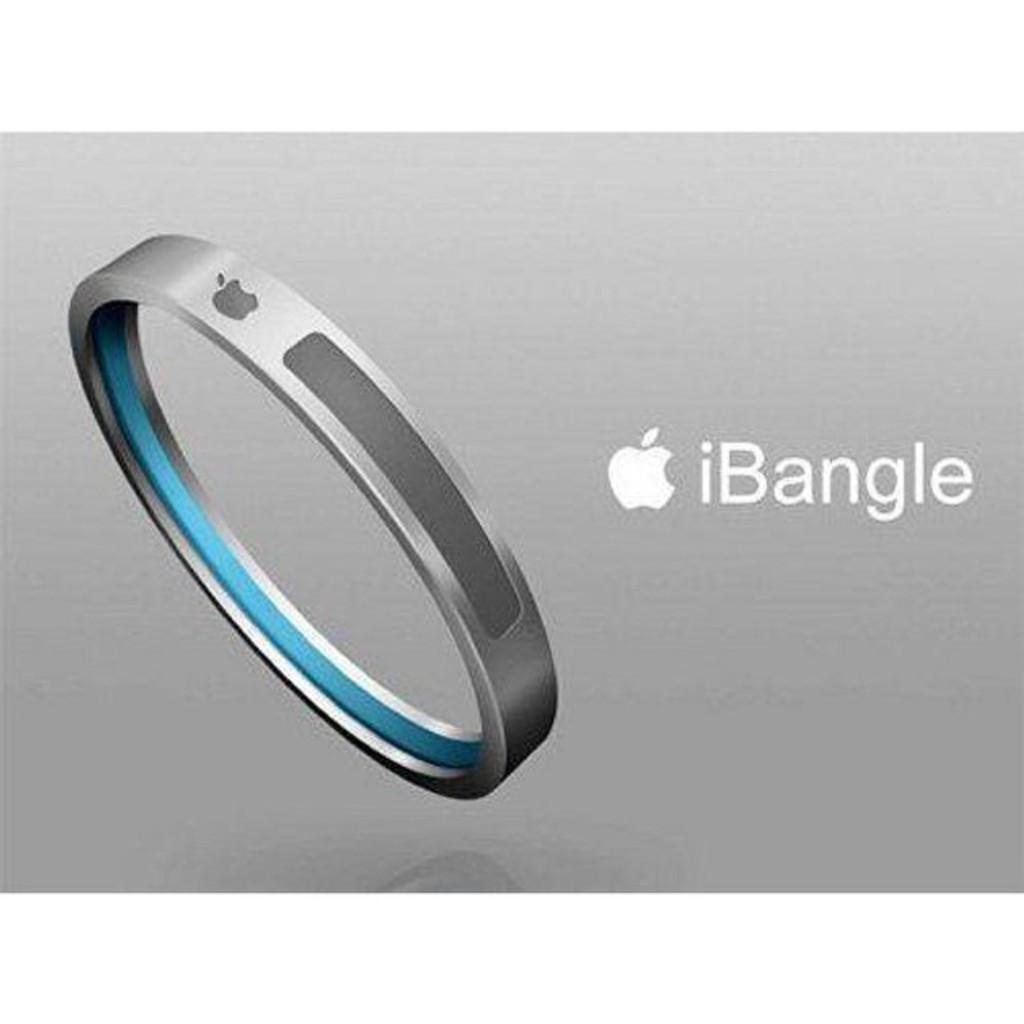<image>
Render a clear and concise summary of the photo. a round bracelet that has the word iBangle next to it 